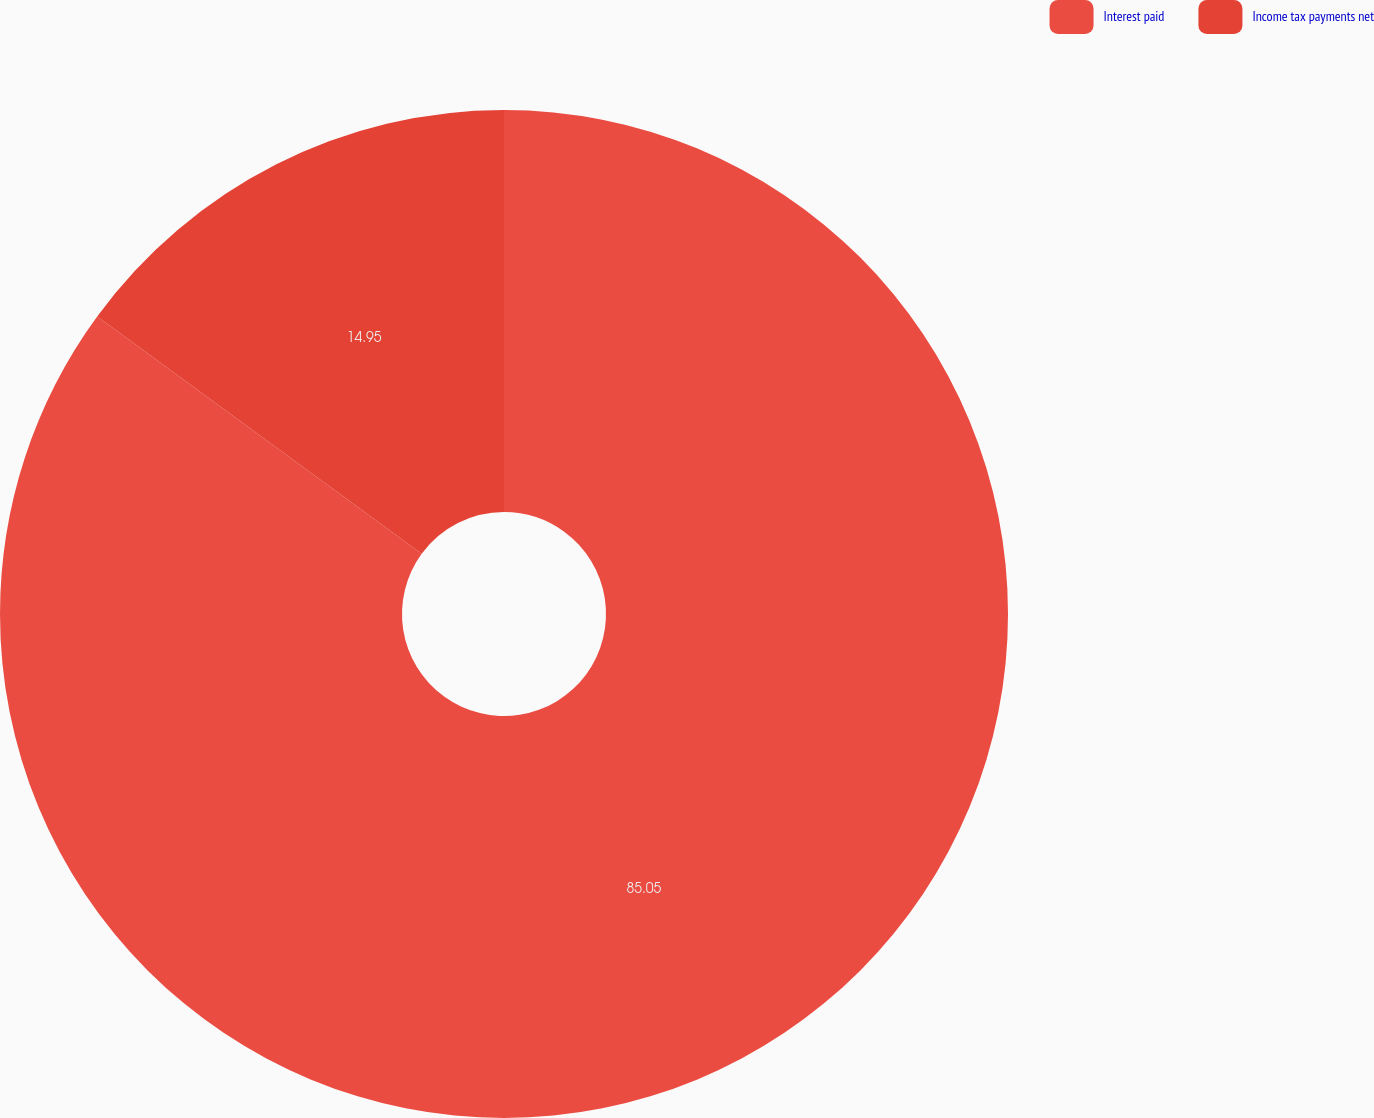Convert chart. <chart><loc_0><loc_0><loc_500><loc_500><pie_chart><fcel>Interest paid<fcel>Income tax payments net<nl><fcel>85.05%<fcel>14.95%<nl></chart> 